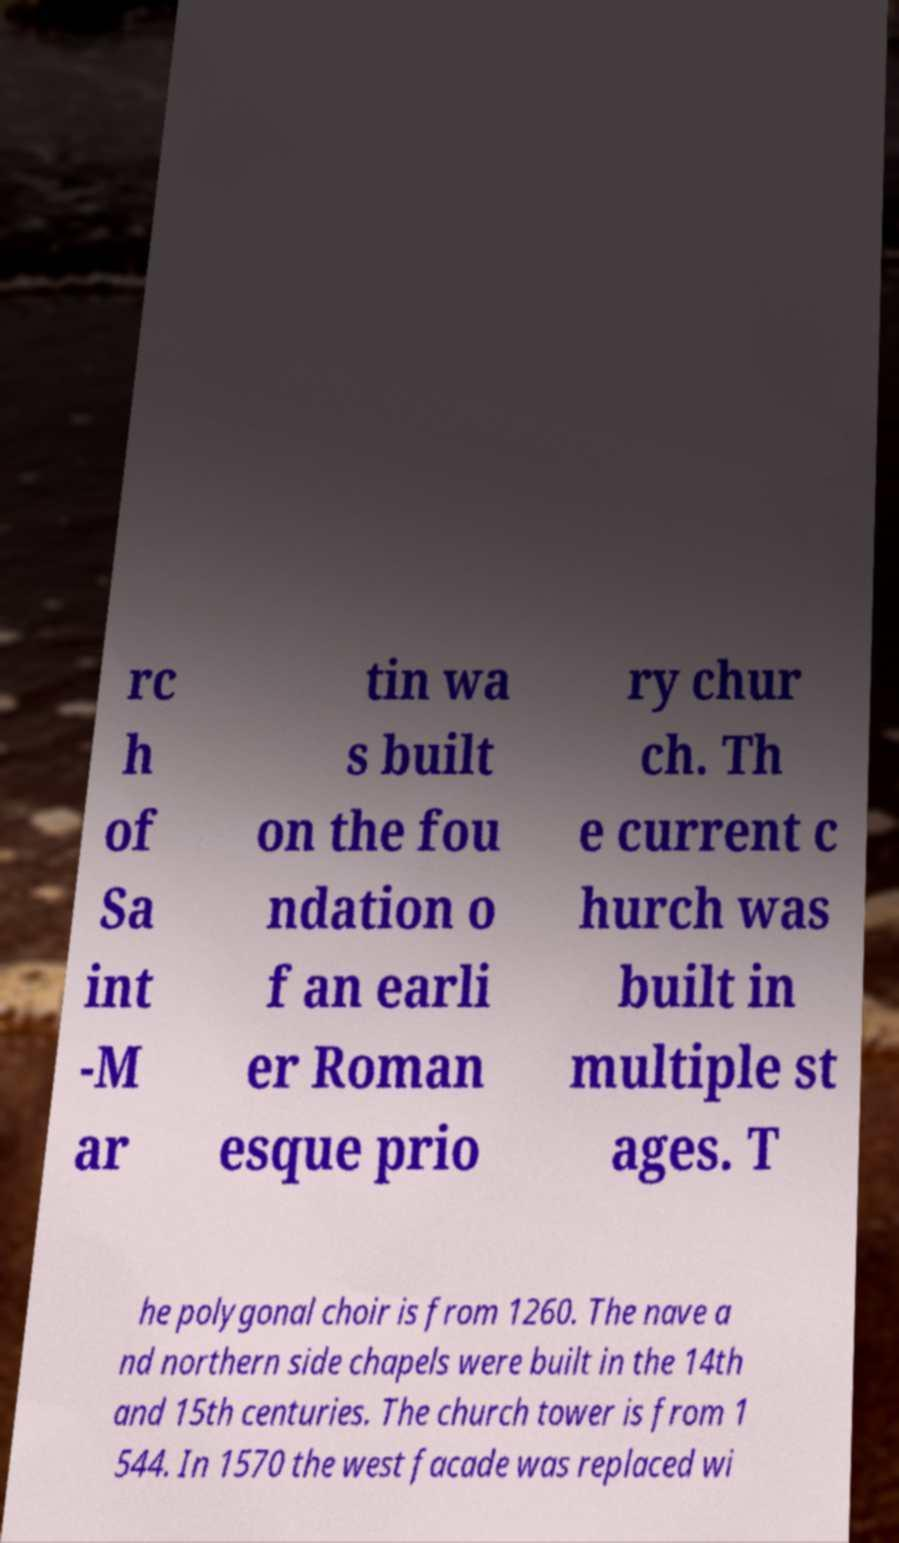Please read and relay the text visible in this image. What does it say? rc h of Sa int -M ar tin wa s built on the fou ndation o f an earli er Roman esque prio ry chur ch. Th e current c hurch was built in multiple st ages. T he polygonal choir is from 1260. The nave a nd northern side chapels were built in the 14th and 15th centuries. The church tower is from 1 544. In 1570 the west facade was replaced wi 